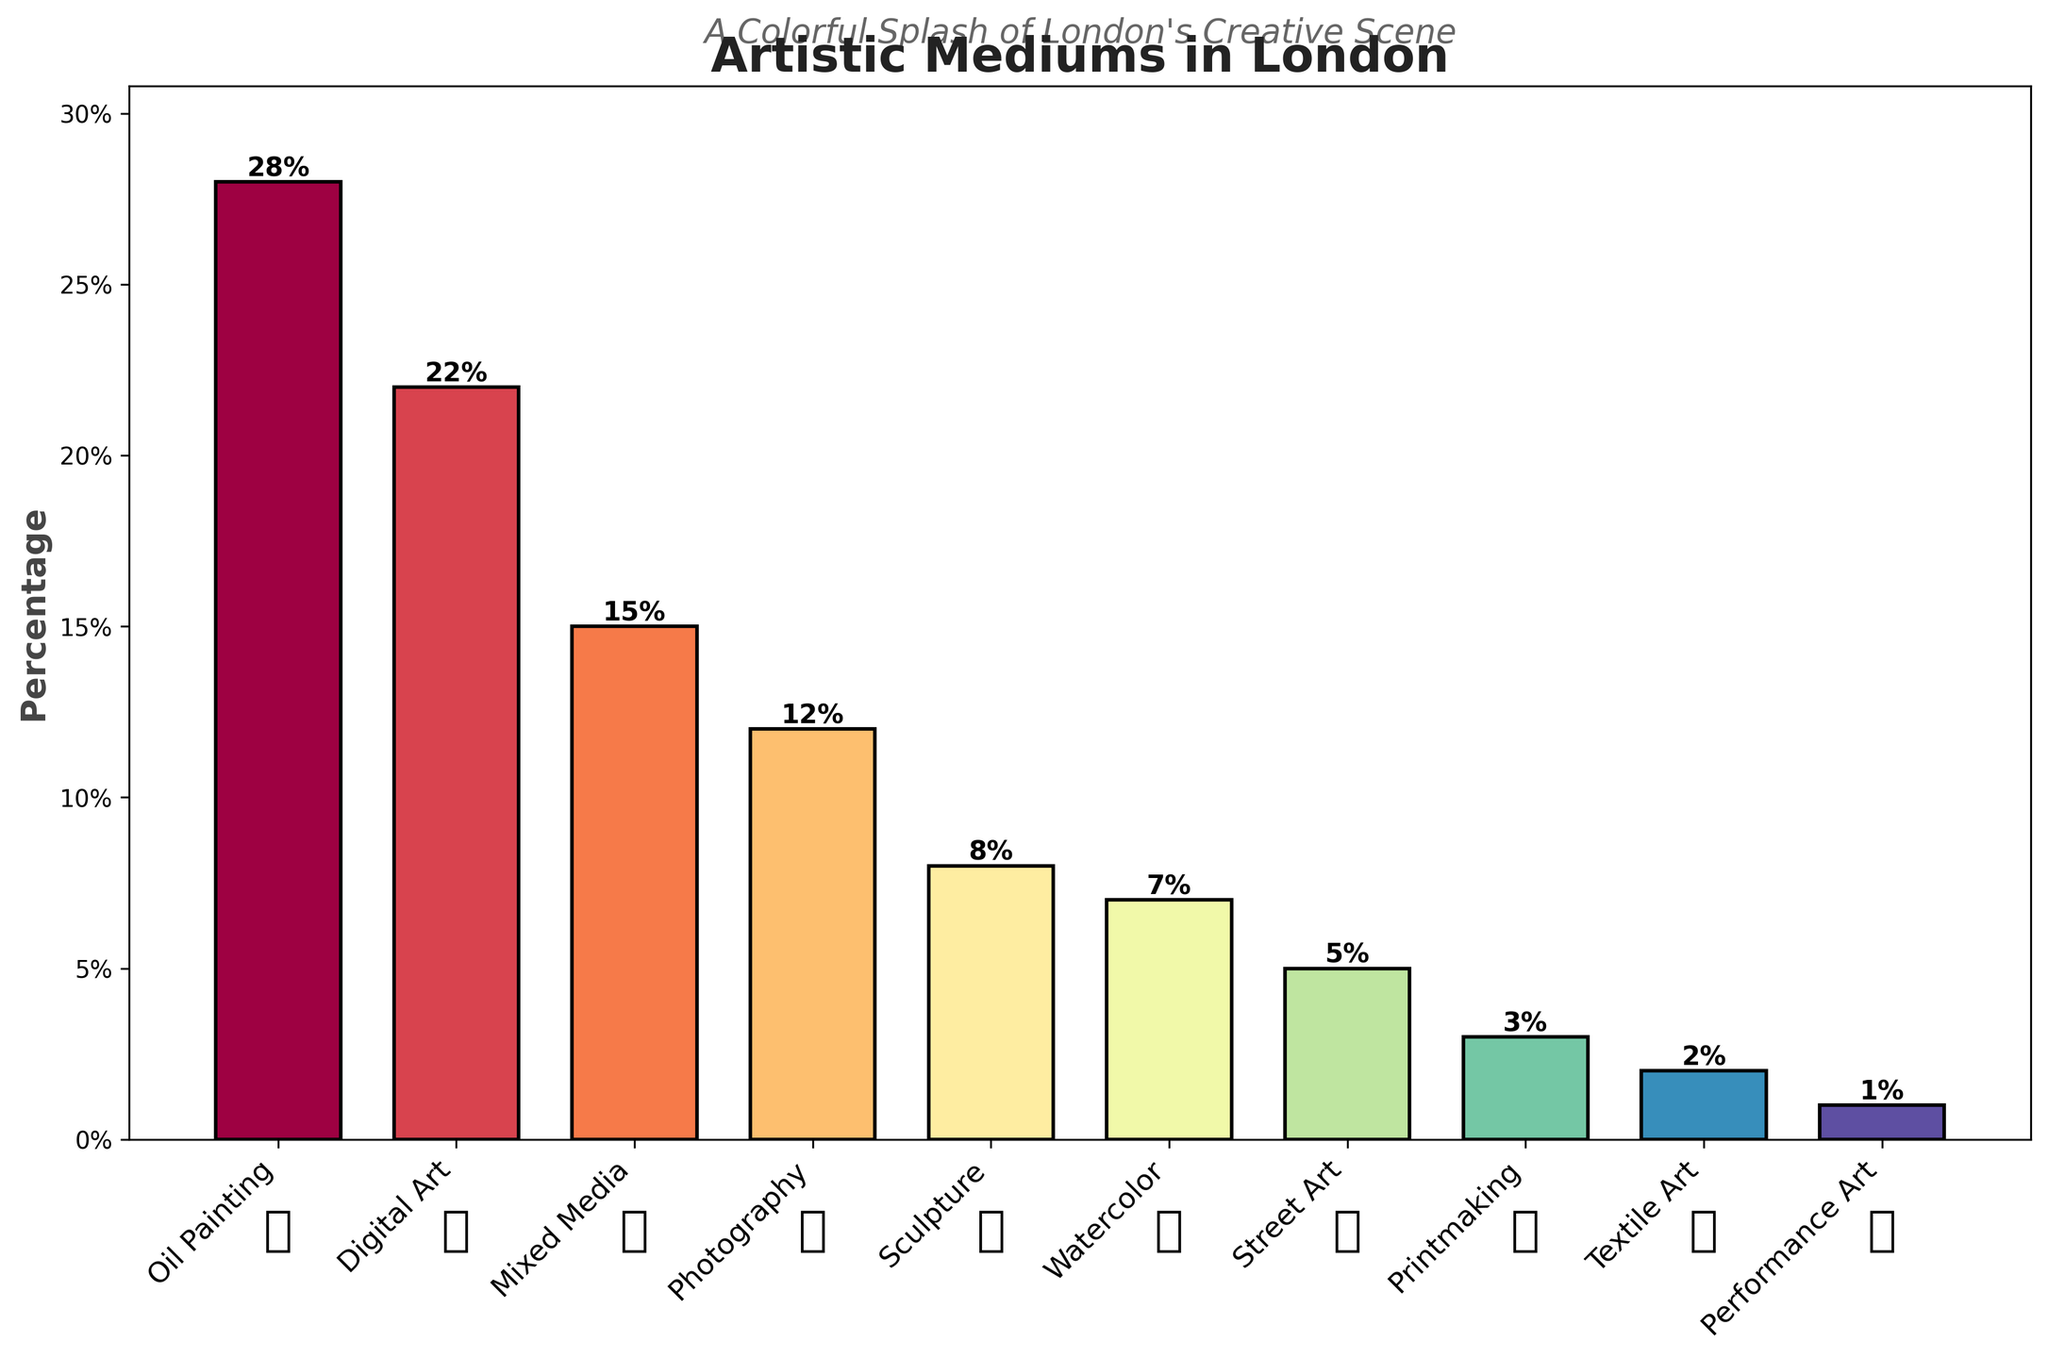What is the percentage of artists using Oil Painting? The bar labeled "Oil Painting" shows a height corresponding to 28%.
Answer: 28% Which artistic medium has the lowest percentage? The bar for "Performance Art" is the shortest, indicating it has the lowest percentage at 1%.
Answer: Performance Art What is the percentage difference between Digital Art and Watercolor? The percentage for Digital Art is 22%, and for Watercolor, it is 7%. The difference is 22% - 7% = 15%.
Answer: 15% Are there more artists using Mixed Media or Photography? The bar for Mixed Media shows a percentage of 15%, while Photography shows 12%. Therefore, more artists use Mixed Media.
Answer: Mixed Media What is the combined percentage of artists using Sculpture, Watercolor, and Street Art? The percentages for Sculpture, Watercolor, and Street Art are 8%, 7%, and 5% respectively. Adding them together: 8% + 7% + 5% = 20%.
Answer: 20% Which artistic medium is exactly in the middle, in terms of percentage from highest to lowest? When ordered by percentage: Oil Painting (28%), Digital Art (22%), Mixed Media (15%), Photography (12%), Sculpture (8%), Watercolor (7%), Street Art (5%), Printmaking (3%), Textile Art (2%), Performance Art (1%). The middle value is Sculpture at 8%.
Answer: Sculpture How many artistic mediums have a percentage of 5% or less? By examining the bars, Street Art (5%), Printmaking (3%), Textile Art (2%), and Performance Art (1%) all have percentages of 5% or less. This gives a total of 4 artistic mediums.
Answer: 4 mediums Which has a greater percentage, Watercolor or Printmaking, and by how much? Watercolor has a percentage of 7%, while Printmaking has 3%. The difference is 7% - 3% = 4%.
Answer: Watercolor by 4% What percentage of artists use unconventional mediums like Street Art or Performance Art? Adding the percentages for Street Art (5%) and Performance Art (1%): 5% + 1% = 6%.
Answer: 6% How does the percentage of artists using Digital Art compare to the percentage using Street Art? The percentage for Digital Art is 22%, while Street Art is 5%. Digital Art has a higher percentage than Street Art.
Answer: Digital Art has a higher percentage 